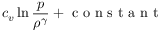Convert formula to latex. <formula><loc_0><loc_0><loc_500><loc_500>c _ { v } \ln \frac { p } { \rho ^ { \gamma } } + c o n s t a n t</formula> 